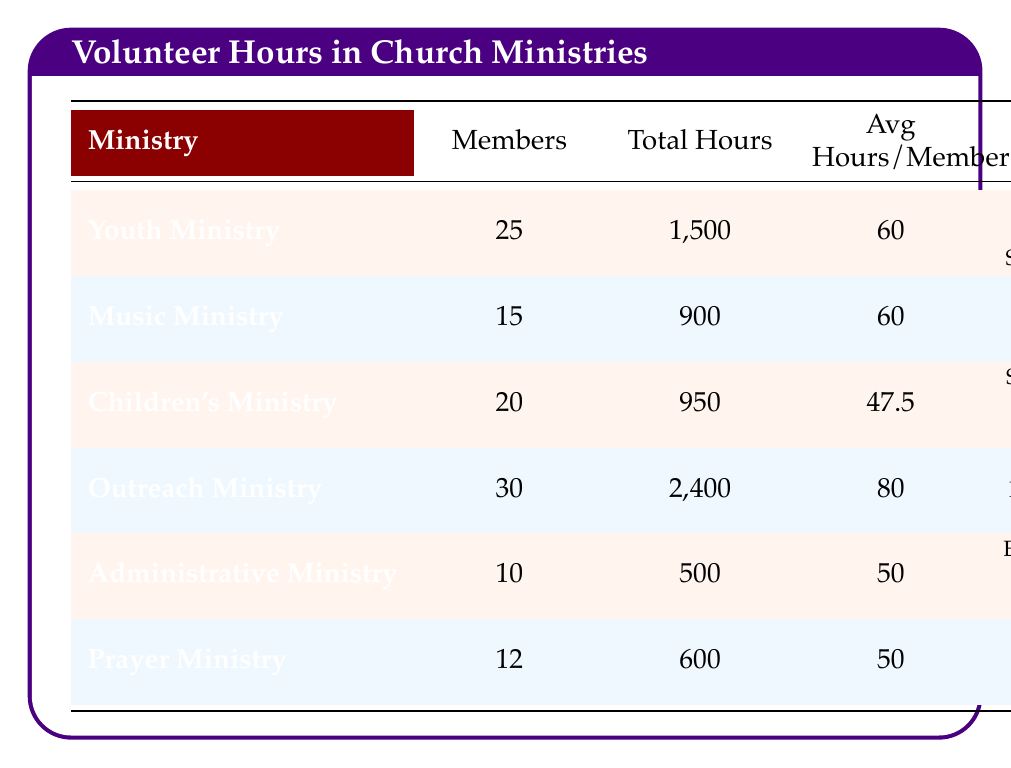What is the total number of volunteer hours contributed by the Outreach Ministry? The table shows that the total hours for the Outreach Ministry is listed directly under the "Total Hours" column, which is 2,400.
Answer: 2,400 How many members are involved in the Youth Ministry? The number of members in the Youth Ministry can be found in the "Members" column, which states that there are 25 members.
Answer: 25 What is the average number of volunteer hours per member in the Children's Ministry? To find the average hours per member for the Children's Ministry, refer to the "Avg Hours/Member" column, which indicates the average as 47.5.
Answer: 47.5 Which ministry had the highest average hours contributed per member? Reviewing the "Avg Hours/Member" column, the Outreach Ministry has the highest average at 80.
Answer: Outreach Ministry What are the main activities of the Music Ministry? The main activities are listed in the "Main Activities" column for the Music Ministry, which includes Rehearsals, Performances, and Concerts.
Answer: Rehearsals, Performances, Concerts What is the difference in total volunteer hours between the Youth Ministry and the Administrative Ministry? The total hours for the Youth Ministry is 1,500 and for the Administrative Ministry is 500. The difference is 1,500 - 500 = 1,000.
Answer: 1,000 What percentage of the total volunteer hours came from the Outreach Ministry? The total hours from the Outreach Ministry is 2,400. Adding all the total hours gives 5,450 (1,500 + 900 + 950 + 2,400 + 500 + 600). The percentage is (2,400 / 5,450) * 100 ≈ 43.96%.
Answer: 43.96% Is the average member contribution in the Prayer Ministry higher than that in the Administrative Ministry? The average for the Prayer Ministry is 50 and for the Administrative Ministry is also 50. They are equal, so the answer is no.
Answer: No How many total volunteer hours were contributed by all ministries combined? The total hours can be calculated by summing the values from the "Total Hours" column: 1,500 + 900 + 950 + 2,400 + 500 + 600 = 5,850.
Answer: 5,850 If you combine the members of the Youth and Music Ministries, how many members are there in total? The Youth Ministry has 25 members and the Music Ministry has 15 members. Adding them gives 25 + 15 = 40.
Answer: 40 